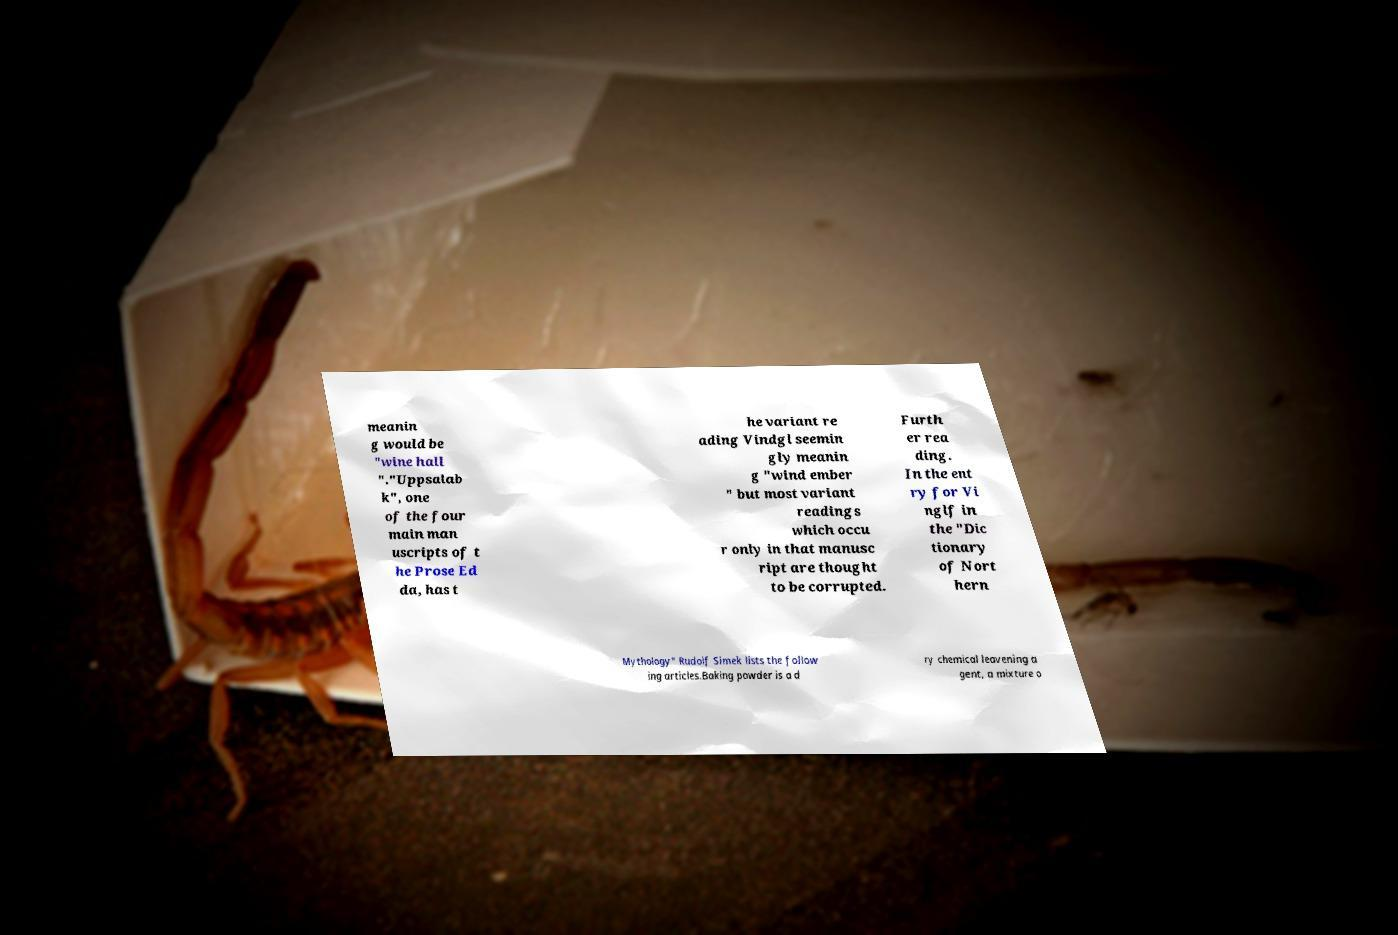What messages or text are displayed in this image? I need them in a readable, typed format. meanin g would be "wine hall "."Uppsalab k", one of the four main man uscripts of t he Prose Ed da, has t he variant re ading Vindgl seemin gly meanin g "wind ember " but most variant readings which occu r only in that manusc ript are thought to be corrupted. Furth er rea ding. In the ent ry for Vi nglf in the "Dic tionary of Nort hern Mythology" Rudolf Simek lists the follow ing articles.Baking powder is a d ry chemical leavening a gent, a mixture o 